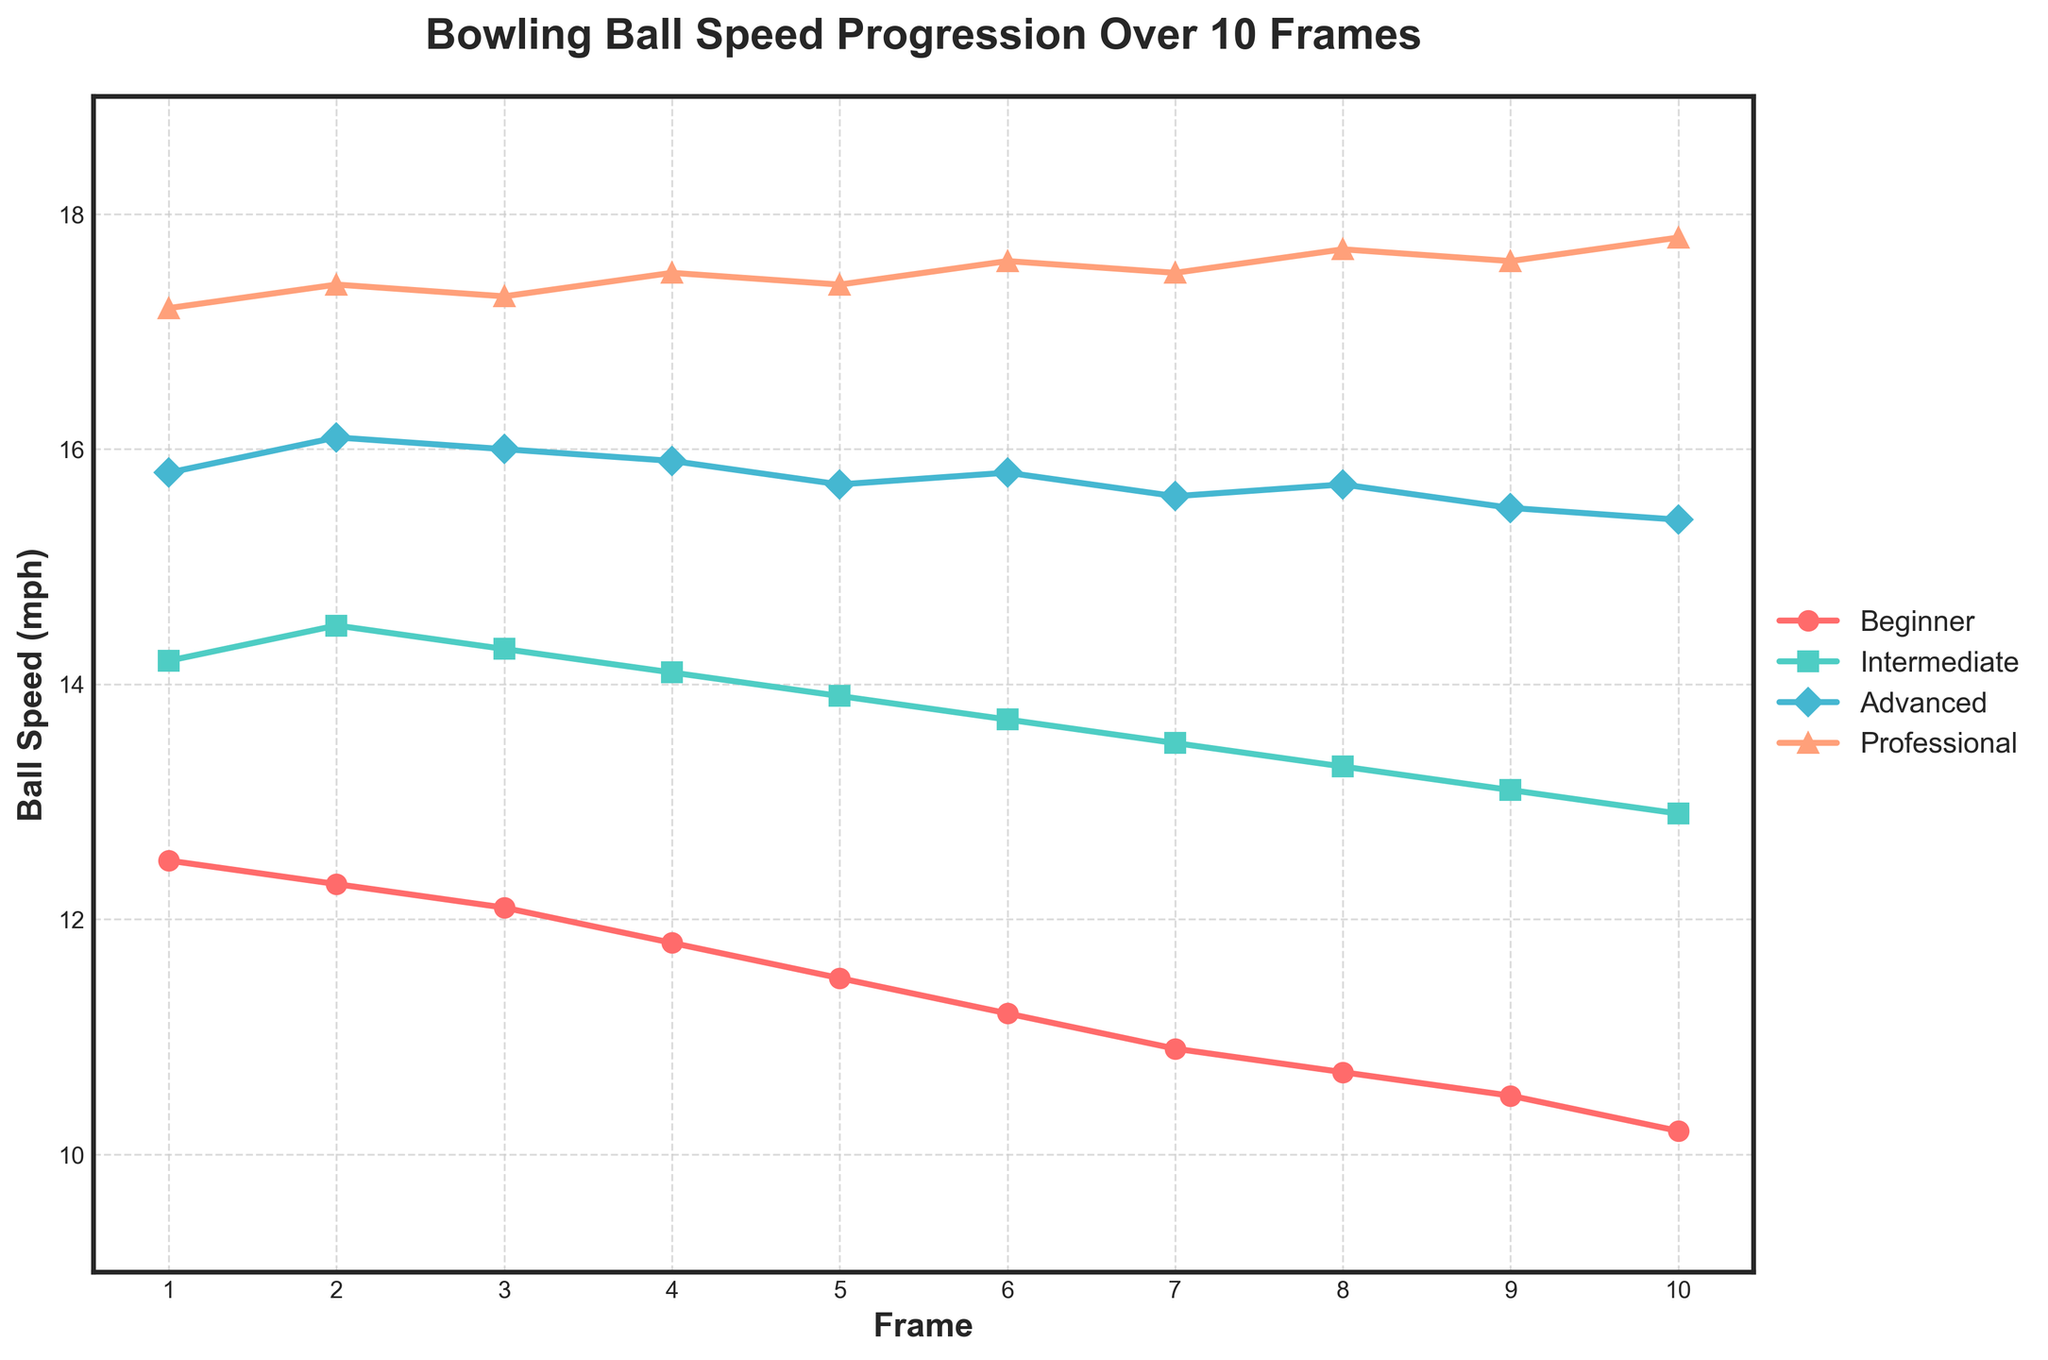What is the ball speed for the Beginner and Professional at Frame 5? Check the line chart at Frame 5 and note the respective speeds for the Beginner and Professional. The Beginner's speed is 11.5 mph, and the Professional's speed is 17.4 mph.
Answer: Beginner: 11.5 mph, Professional: 17.4 mph Which skill level shows the most consistent ball speed throughout the 10 frames? Analyze the line chart for each skill level. The Professional line remains relatively stable and consistently high, indicating the most consistent performance.
Answer: Professional At which frame does the Intermediate's ball speed decrease the most? Examine the Intermediate line. The most significant drop happens between Frame 1 and Frame 2, from 14.2 mph to 14.5 mph.
Answer: Between Frame 1 and Frame 2 How does the ball speed of the Advanced level compare to that of the Beginner level at Frame 7? Look at the speeds at Frame 7 for both levels. Advanced is at 15.6 mph and Beginner is at 10.9 mph. The Advanced speed is substantially higher.
Answer: Advanced: 15.6 mph, Beginner: 10.9 mph What is the average speed of the Intermediate level over the 10 frames? Sum the ball speeds for the Intermediate level across all frames (14.2 + 14.5 + 14.3 + 14.1 + 13.9 + 13.7 + 13.5 + 13.3 + 13.1 + 12.9) and then divide by 10 frames. The total is 137.5, so the average is 137.5/10.
Answer: 13.75 mph Which frame shows the highest ball speed for the Professional level? Look for the peak value on the Professional's line. The highest ball speed is 17.8 mph at Frame 10.
Answer: Frame 10 Compare the Beginner's ball speed progression with the Intermediate's. How do their trends differ? Observe the Beginner and Intermediate lines. The Beginner's speed steadily decreases, while the Intermediate's speed also decreases but at a slower and more fluctuating rate.
Answer: Beginner: steady decrease, Intermediate: slower, fluctuating decrease Which skill level has the least consistent ball speed progression over the frames? Notice the lines with the most fluctuations. The Intermediate skill level shows the most fluctuations, indicating the least consistency.
Answer: Intermediate 